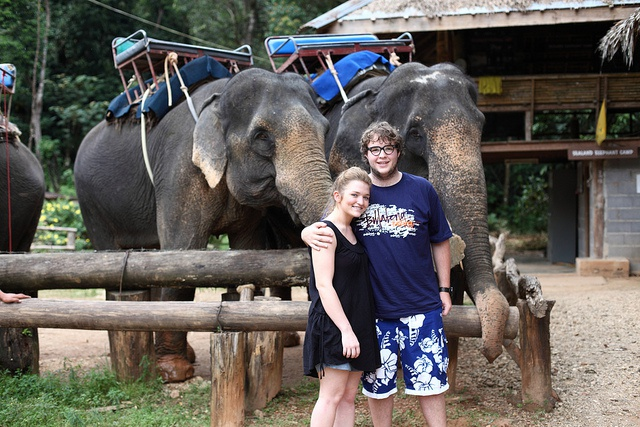Describe the objects in this image and their specific colors. I can see elephant in darkgreen, gray, black, darkgray, and maroon tones, elephant in darkgreen, gray, black, and darkgray tones, people in darkgreen, navy, black, white, and gray tones, people in darkgreen, black, lightgray, lightpink, and gray tones, and bench in darkgreen, black, gray, darkgray, and lavender tones in this image. 